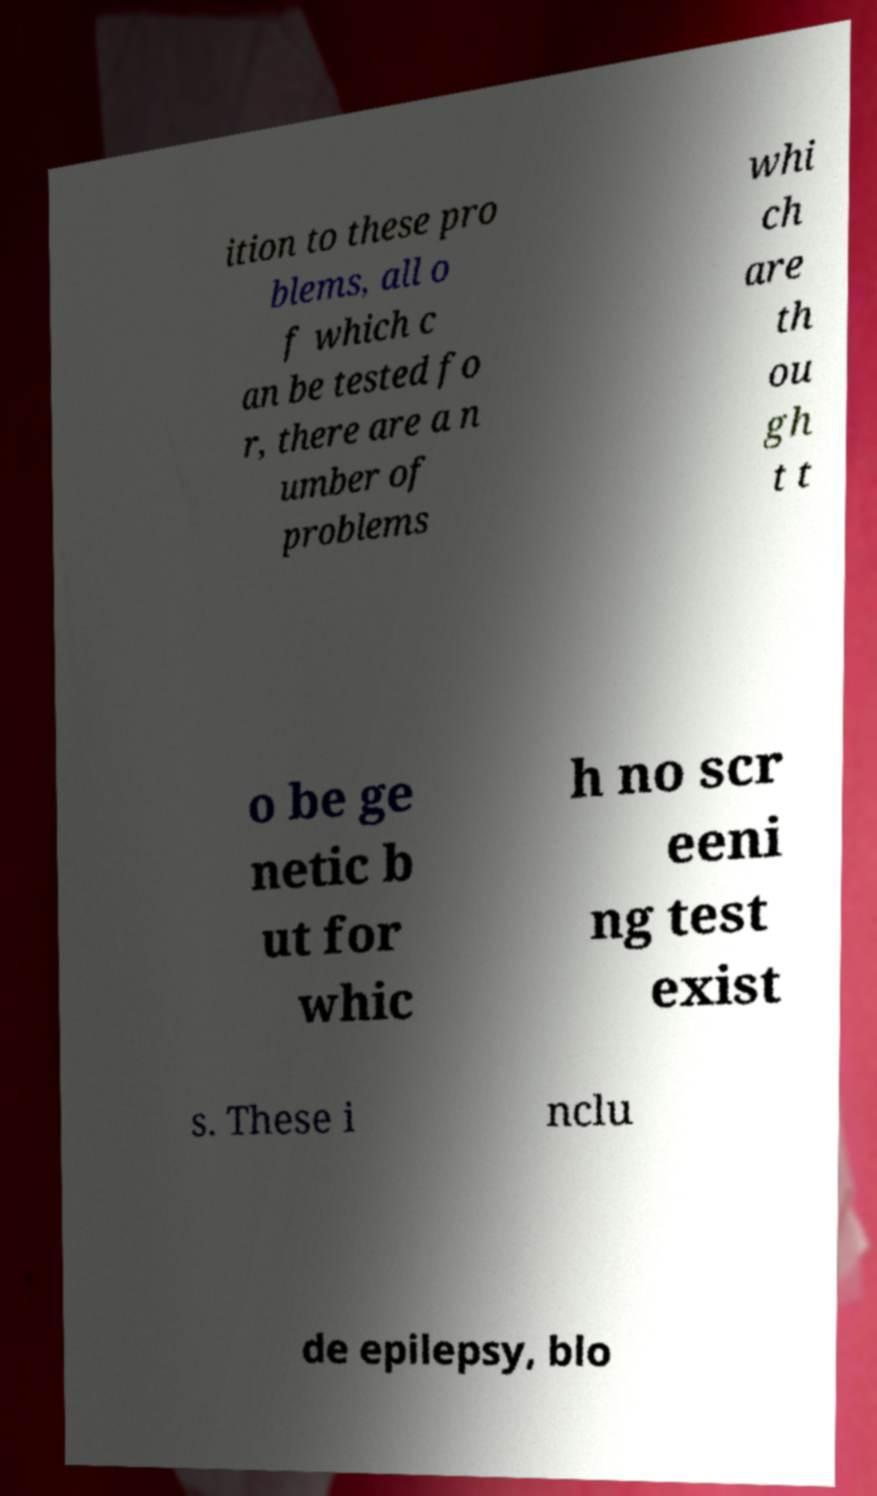Could you assist in decoding the text presented in this image and type it out clearly? ition to these pro blems, all o f which c an be tested fo r, there are a n umber of problems whi ch are th ou gh t t o be ge netic b ut for whic h no scr eeni ng test exist s. These i nclu de epilepsy, blo 